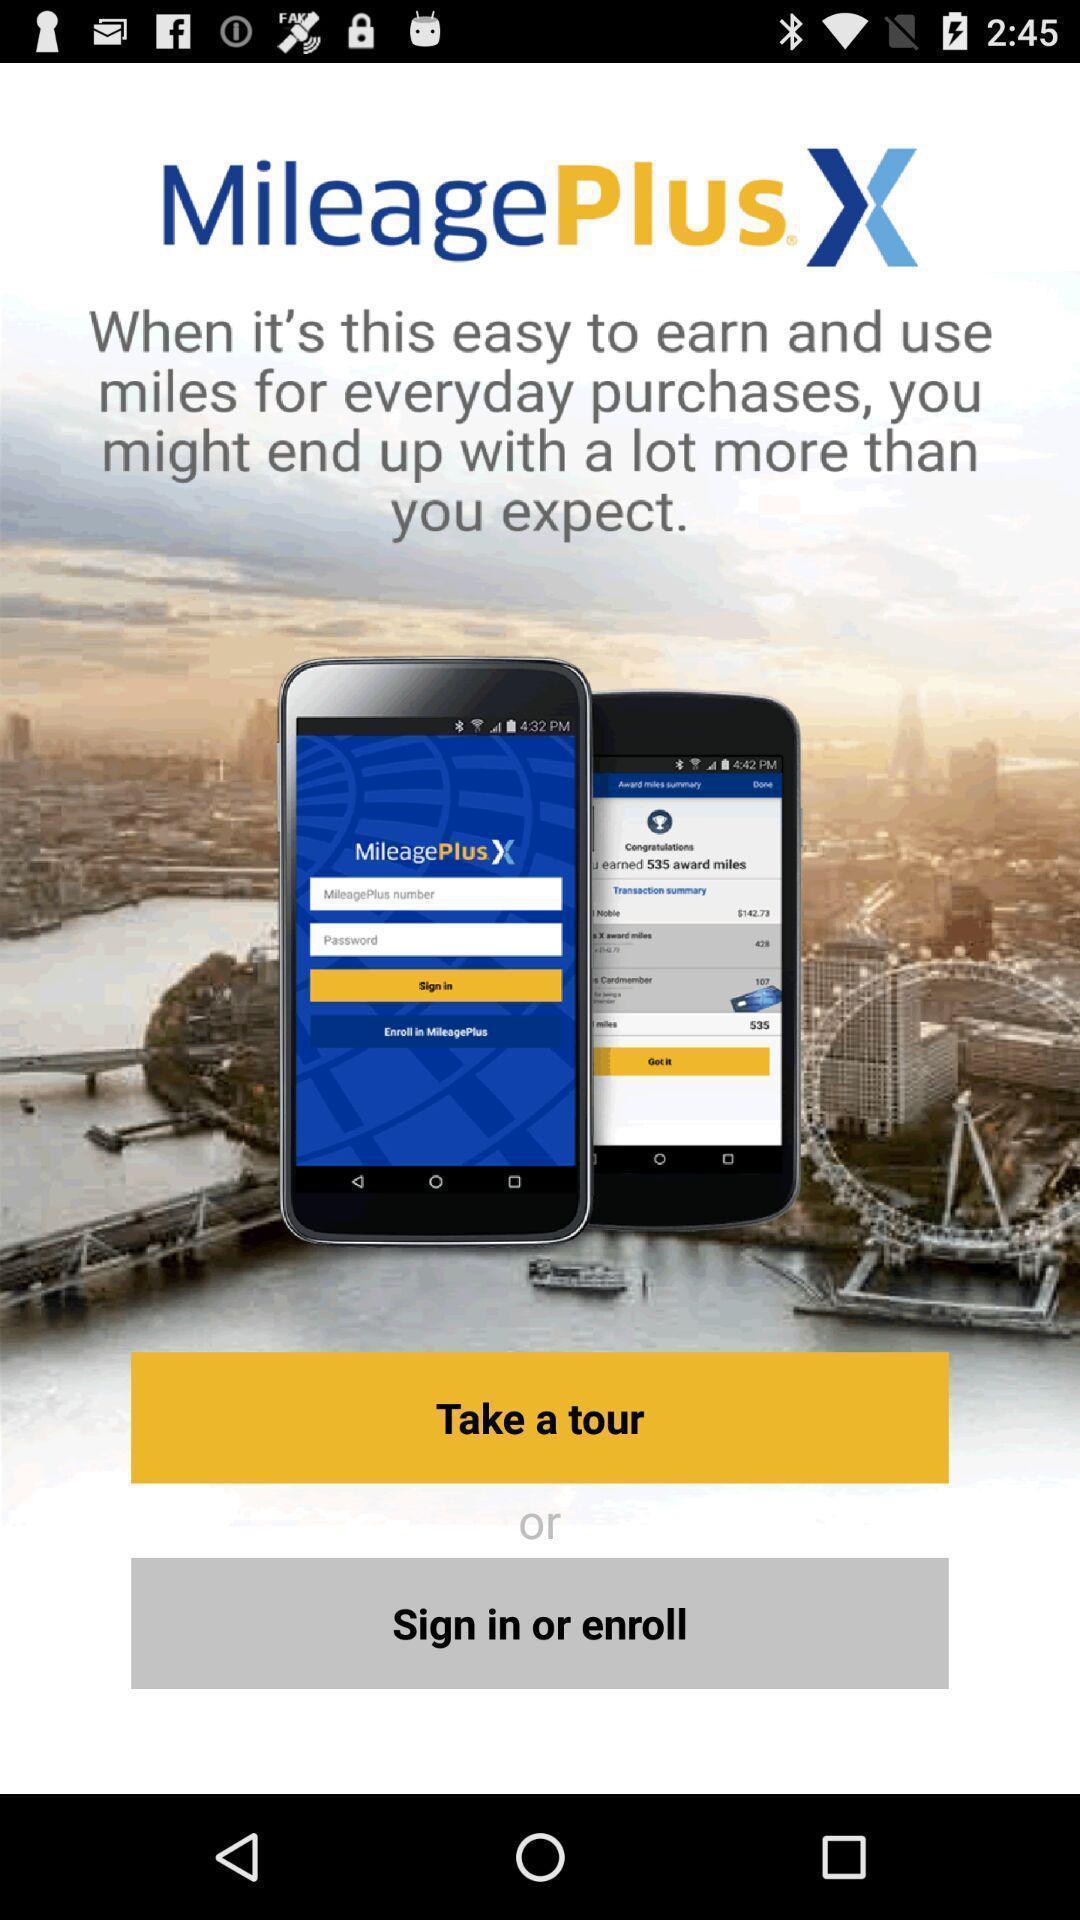Tell me what you see in this picture. Welcome page of travel application. 